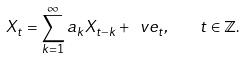<formula> <loc_0><loc_0><loc_500><loc_500>X _ { t } = \sum _ { k = 1 } ^ { \infty } a _ { k } X _ { t - k } + \ v e _ { t } , \quad t \in \mathbb { Z } .</formula> 